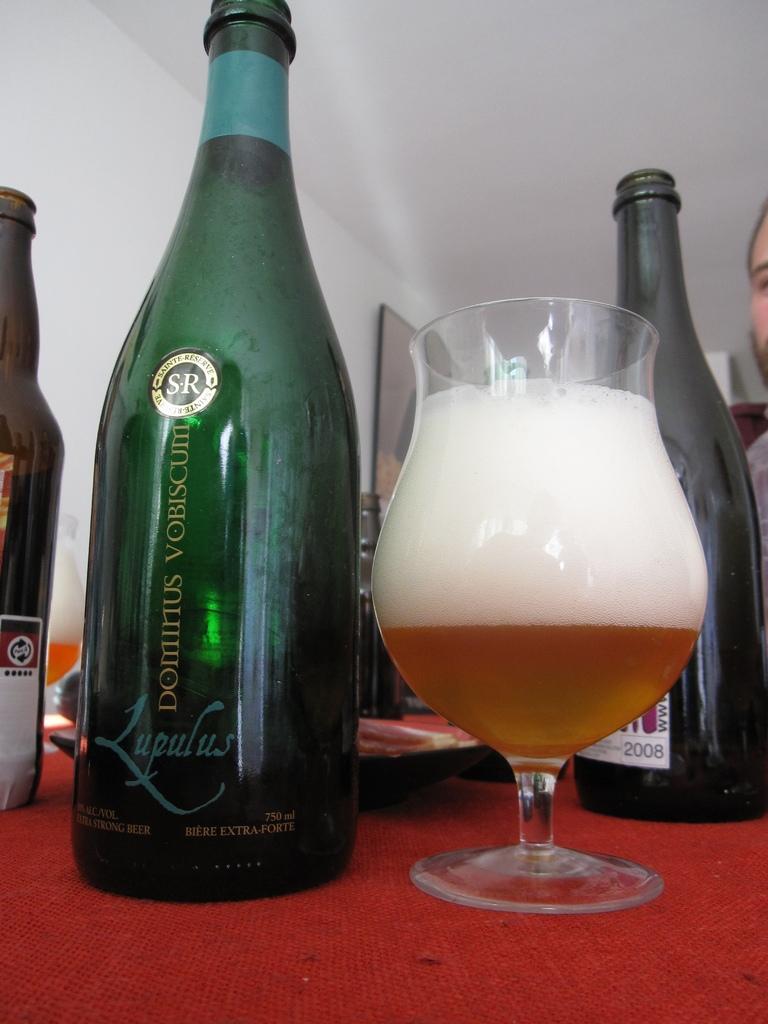Describe this image in one or two sentences. In this picture we can see bottles, and a glass on the table. On the background there is a wall and this is the frame. 